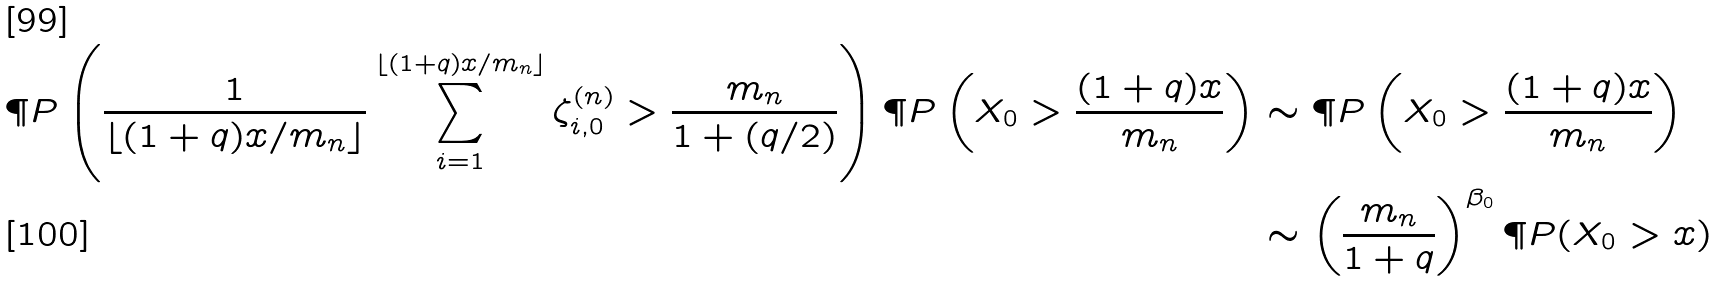<formula> <loc_0><loc_0><loc_500><loc_500>\P P \left ( \frac { 1 } { \lfloor ( 1 + q ) x / m _ { n } \rfloor } \sum _ { i = 1 } ^ { \lfloor ( 1 + q ) x / m _ { n } \rfloor } \zeta _ { i , 0 } ^ { ( n ) } > \frac { m _ { n } } { 1 + ( q / 2 ) } \right ) \P P \left ( X _ { 0 } > \frac { ( 1 + q ) x } { m _ { n } } \right ) & \sim \P P \left ( X _ { 0 } > \frac { ( 1 + q ) x } { m _ { n } } \right ) \\ & \sim \left ( \frac { m _ { n } } { 1 + q } \right ) ^ { \beta _ { 0 } } \P P ( X _ { 0 } > x )</formula> 